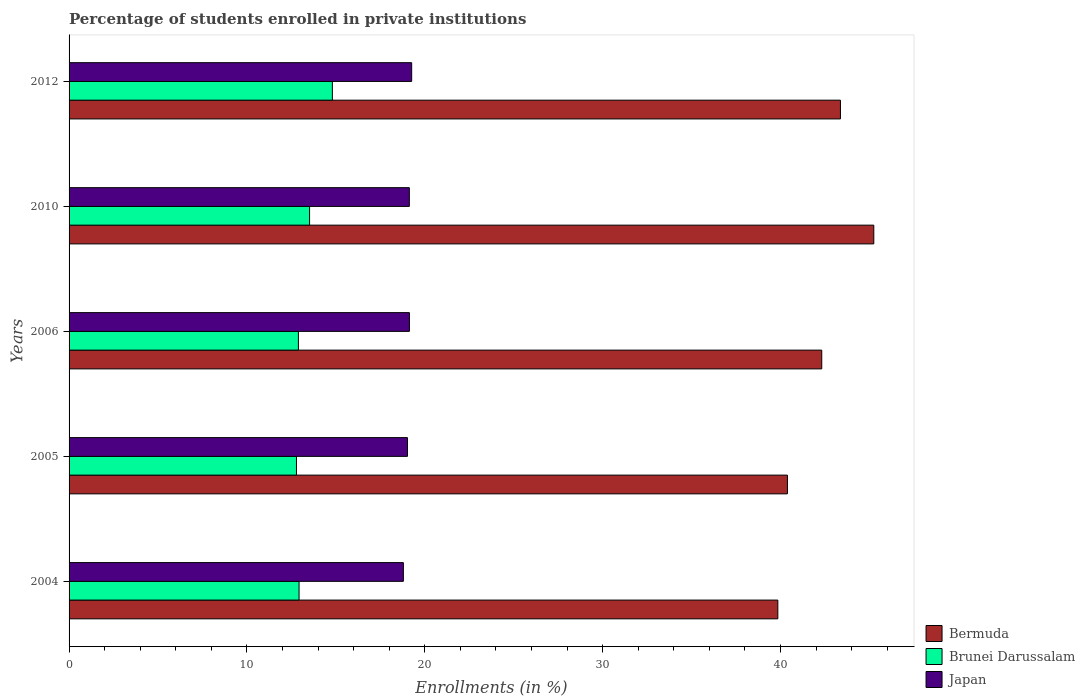How many different coloured bars are there?
Ensure brevity in your answer.  3. Are the number of bars per tick equal to the number of legend labels?
Offer a very short reply. Yes. What is the label of the 1st group of bars from the top?
Provide a succinct answer. 2012. In how many cases, is the number of bars for a given year not equal to the number of legend labels?
Make the answer very short. 0. What is the percentage of trained teachers in Brunei Darussalam in 2006?
Your answer should be compact. 12.89. Across all years, what is the maximum percentage of trained teachers in Brunei Darussalam?
Keep it short and to the point. 14.8. Across all years, what is the minimum percentage of trained teachers in Bermuda?
Offer a very short reply. 39.85. In which year was the percentage of trained teachers in Bermuda maximum?
Provide a succinct answer. 2010. In which year was the percentage of trained teachers in Bermuda minimum?
Provide a succinct answer. 2004. What is the total percentage of trained teachers in Japan in the graph?
Your answer should be very brief. 95.35. What is the difference between the percentage of trained teachers in Bermuda in 2010 and that in 2012?
Provide a short and direct response. 1.88. What is the difference between the percentage of trained teachers in Brunei Darussalam in 2010 and the percentage of trained teachers in Bermuda in 2012?
Provide a short and direct response. -29.85. What is the average percentage of trained teachers in Bermuda per year?
Your answer should be very brief. 42.24. In the year 2012, what is the difference between the percentage of trained teachers in Japan and percentage of trained teachers in Bermuda?
Provide a succinct answer. -24.11. In how many years, is the percentage of trained teachers in Brunei Darussalam greater than 18 %?
Make the answer very short. 0. What is the ratio of the percentage of trained teachers in Brunei Darussalam in 2005 to that in 2006?
Provide a short and direct response. 0.99. Is the percentage of trained teachers in Bermuda in 2006 less than that in 2010?
Provide a succinct answer. Yes. Is the difference between the percentage of trained teachers in Japan in 2010 and 2012 greater than the difference between the percentage of trained teachers in Bermuda in 2010 and 2012?
Offer a terse response. No. What is the difference between the highest and the second highest percentage of trained teachers in Bermuda?
Provide a succinct answer. 1.88. What is the difference between the highest and the lowest percentage of trained teachers in Brunei Darussalam?
Give a very brief answer. 2.02. In how many years, is the percentage of trained teachers in Japan greater than the average percentage of trained teachers in Japan taken over all years?
Your response must be concise. 3. Is the sum of the percentage of trained teachers in Bermuda in 2005 and 2012 greater than the maximum percentage of trained teachers in Japan across all years?
Provide a succinct answer. Yes. What does the 2nd bar from the top in 2012 represents?
Offer a terse response. Brunei Darussalam. How many bars are there?
Offer a terse response. 15. Are all the bars in the graph horizontal?
Your answer should be very brief. Yes. Are the values on the major ticks of X-axis written in scientific E-notation?
Make the answer very short. No. Where does the legend appear in the graph?
Make the answer very short. Bottom right. How are the legend labels stacked?
Offer a terse response. Vertical. What is the title of the graph?
Give a very brief answer. Percentage of students enrolled in private institutions. Does "Azerbaijan" appear as one of the legend labels in the graph?
Offer a very short reply. No. What is the label or title of the X-axis?
Offer a very short reply. Enrollments (in %). What is the Enrollments (in %) of Bermuda in 2004?
Your response must be concise. 39.85. What is the Enrollments (in %) of Brunei Darussalam in 2004?
Provide a short and direct response. 12.93. What is the Enrollments (in %) of Japan in 2004?
Your answer should be compact. 18.8. What is the Enrollments (in %) of Bermuda in 2005?
Give a very brief answer. 40.39. What is the Enrollments (in %) in Brunei Darussalam in 2005?
Ensure brevity in your answer.  12.79. What is the Enrollments (in %) of Japan in 2005?
Offer a terse response. 19.03. What is the Enrollments (in %) in Bermuda in 2006?
Your response must be concise. 42.32. What is the Enrollments (in %) in Brunei Darussalam in 2006?
Your answer should be compact. 12.89. What is the Enrollments (in %) in Japan in 2006?
Your answer should be very brief. 19.14. What is the Enrollments (in %) in Bermuda in 2010?
Make the answer very short. 45.25. What is the Enrollments (in %) in Brunei Darussalam in 2010?
Make the answer very short. 13.52. What is the Enrollments (in %) in Japan in 2010?
Keep it short and to the point. 19.13. What is the Enrollments (in %) of Bermuda in 2012?
Your answer should be compact. 43.37. What is the Enrollments (in %) of Brunei Darussalam in 2012?
Offer a terse response. 14.8. What is the Enrollments (in %) in Japan in 2012?
Keep it short and to the point. 19.26. Across all years, what is the maximum Enrollments (in %) of Bermuda?
Provide a succinct answer. 45.25. Across all years, what is the maximum Enrollments (in %) in Brunei Darussalam?
Offer a terse response. 14.8. Across all years, what is the maximum Enrollments (in %) in Japan?
Give a very brief answer. 19.26. Across all years, what is the minimum Enrollments (in %) of Bermuda?
Your answer should be compact. 39.85. Across all years, what is the minimum Enrollments (in %) of Brunei Darussalam?
Provide a short and direct response. 12.79. Across all years, what is the minimum Enrollments (in %) of Japan?
Provide a short and direct response. 18.8. What is the total Enrollments (in %) of Bermuda in the graph?
Your response must be concise. 211.18. What is the total Enrollments (in %) in Brunei Darussalam in the graph?
Provide a short and direct response. 66.94. What is the total Enrollments (in %) of Japan in the graph?
Make the answer very short. 95.35. What is the difference between the Enrollments (in %) of Bermuda in 2004 and that in 2005?
Make the answer very short. -0.54. What is the difference between the Enrollments (in %) in Brunei Darussalam in 2004 and that in 2005?
Provide a short and direct response. 0.15. What is the difference between the Enrollments (in %) in Japan in 2004 and that in 2005?
Offer a terse response. -0.23. What is the difference between the Enrollments (in %) in Bermuda in 2004 and that in 2006?
Offer a very short reply. -2.47. What is the difference between the Enrollments (in %) of Brunei Darussalam in 2004 and that in 2006?
Provide a short and direct response. 0.04. What is the difference between the Enrollments (in %) in Japan in 2004 and that in 2006?
Offer a very short reply. -0.34. What is the difference between the Enrollments (in %) in Bermuda in 2004 and that in 2010?
Make the answer very short. -5.4. What is the difference between the Enrollments (in %) of Brunei Darussalam in 2004 and that in 2010?
Your response must be concise. -0.59. What is the difference between the Enrollments (in %) in Japan in 2004 and that in 2010?
Provide a short and direct response. -0.34. What is the difference between the Enrollments (in %) of Bermuda in 2004 and that in 2012?
Provide a succinct answer. -3.52. What is the difference between the Enrollments (in %) of Brunei Darussalam in 2004 and that in 2012?
Your answer should be very brief. -1.87. What is the difference between the Enrollments (in %) in Japan in 2004 and that in 2012?
Your answer should be very brief. -0.47. What is the difference between the Enrollments (in %) of Bermuda in 2005 and that in 2006?
Provide a succinct answer. -1.93. What is the difference between the Enrollments (in %) in Brunei Darussalam in 2005 and that in 2006?
Offer a very short reply. -0.11. What is the difference between the Enrollments (in %) in Japan in 2005 and that in 2006?
Your response must be concise. -0.11. What is the difference between the Enrollments (in %) of Bermuda in 2005 and that in 2010?
Offer a terse response. -4.86. What is the difference between the Enrollments (in %) of Brunei Darussalam in 2005 and that in 2010?
Provide a short and direct response. -0.74. What is the difference between the Enrollments (in %) in Japan in 2005 and that in 2010?
Your response must be concise. -0.11. What is the difference between the Enrollments (in %) of Bermuda in 2005 and that in 2012?
Make the answer very short. -2.98. What is the difference between the Enrollments (in %) in Brunei Darussalam in 2005 and that in 2012?
Give a very brief answer. -2.02. What is the difference between the Enrollments (in %) in Japan in 2005 and that in 2012?
Make the answer very short. -0.24. What is the difference between the Enrollments (in %) of Bermuda in 2006 and that in 2010?
Keep it short and to the point. -2.93. What is the difference between the Enrollments (in %) of Brunei Darussalam in 2006 and that in 2010?
Make the answer very short. -0.63. What is the difference between the Enrollments (in %) of Japan in 2006 and that in 2010?
Offer a terse response. 0. What is the difference between the Enrollments (in %) of Bermuda in 2006 and that in 2012?
Make the answer very short. -1.05. What is the difference between the Enrollments (in %) in Brunei Darussalam in 2006 and that in 2012?
Keep it short and to the point. -1.91. What is the difference between the Enrollments (in %) in Japan in 2006 and that in 2012?
Keep it short and to the point. -0.13. What is the difference between the Enrollments (in %) of Bermuda in 2010 and that in 2012?
Offer a very short reply. 1.88. What is the difference between the Enrollments (in %) in Brunei Darussalam in 2010 and that in 2012?
Your answer should be compact. -1.28. What is the difference between the Enrollments (in %) in Japan in 2010 and that in 2012?
Your response must be concise. -0.13. What is the difference between the Enrollments (in %) of Bermuda in 2004 and the Enrollments (in %) of Brunei Darussalam in 2005?
Your answer should be compact. 27.06. What is the difference between the Enrollments (in %) of Bermuda in 2004 and the Enrollments (in %) of Japan in 2005?
Your answer should be very brief. 20.82. What is the difference between the Enrollments (in %) in Brunei Darussalam in 2004 and the Enrollments (in %) in Japan in 2005?
Your answer should be very brief. -6.09. What is the difference between the Enrollments (in %) of Bermuda in 2004 and the Enrollments (in %) of Brunei Darussalam in 2006?
Offer a very short reply. 26.96. What is the difference between the Enrollments (in %) of Bermuda in 2004 and the Enrollments (in %) of Japan in 2006?
Keep it short and to the point. 20.71. What is the difference between the Enrollments (in %) in Brunei Darussalam in 2004 and the Enrollments (in %) in Japan in 2006?
Your response must be concise. -6.2. What is the difference between the Enrollments (in %) of Bermuda in 2004 and the Enrollments (in %) of Brunei Darussalam in 2010?
Ensure brevity in your answer.  26.33. What is the difference between the Enrollments (in %) in Bermuda in 2004 and the Enrollments (in %) in Japan in 2010?
Ensure brevity in your answer.  20.72. What is the difference between the Enrollments (in %) of Brunei Darussalam in 2004 and the Enrollments (in %) of Japan in 2010?
Your response must be concise. -6.2. What is the difference between the Enrollments (in %) in Bermuda in 2004 and the Enrollments (in %) in Brunei Darussalam in 2012?
Ensure brevity in your answer.  25.05. What is the difference between the Enrollments (in %) in Bermuda in 2004 and the Enrollments (in %) in Japan in 2012?
Provide a succinct answer. 20.59. What is the difference between the Enrollments (in %) of Brunei Darussalam in 2004 and the Enrollments (in %) of Japan in 2012?
Your answer should be compact. -6.33. What is the difference between the Enrollments (in %) of Bermuda in 2005 and the Enrollments (in %) of Brunei Darussalam in 2006?
Your response must be concise. 27.5. What is the difference between the Enrollments (in %) in Bermuda in 2005 and the Enrollments (in %) in Japan in 2006?
Make the answer very short. 21.25. What is the difference between the Enrollments (in %) in Brunei Darussalam in 2005 and the Enrollments (in %) in Japan in 2006?
Provide a succinct answer. -6.35. What is the difference between the Enrollments (in %) in Bermuda in 2005 and the Enrollments (in %) in Brunei Darussalam in 2010?
Give a very brief answer. 26.87. What is the difference between the Enrollments (in %) in Bermuda in 2005 and the Enrollments (in %) in Japan in 2010?
Offer a very short reply. 21.26. What is the difference between the Enrollments (in %) in Brunei Darussalam in 2005 and the Enrollments (in %) in Japan in 2010?
Make the answer very short. -6.35. What is the difference between the Enrollments (in %) of Bermuda in 2005 and the Enrollments (in %) of Brunei Darussalam in 2012?
Your answer should be very brief. 25.59. What is the difference between the Enrollments (in %) in Bermuda in 2005 and the Enrollments (in %) in Japan in 2012?
Your answer should be very brief. 21.13. What is the difference between the Enrollments (in %) of Brunei Darussalam in 2005 and the Enrollments (in %) of Japan in 2012?
Make the answer very short. -6.48. What is the difference between the Enrollments (in %) in Bermuda in 2006 and the Enrollments (in %) in Brunei Darussalam in 2010?
Make the answer very short. 28.8. What is the difference between the Enrollments (in %) of Bermuda in 2006 and the Enrollments (in %) of Japan in 2010?
Offer a very short reply. 23.19. What is the difference between the Enrollments (in %) of Brunei Darussalam in 2006 and the Enrollments (in %) of Japan in 2010?
Your response must be concise. -6.24. What is the difference between the Enrollments (in %) in Bermuda in 2006 and the Enrollments (in %) in Brunei Darussalam in 2012?
Give a very brief answer. 27.52. What is the difference between the Enrollments (in %) of Bermuda in 2006 and the Enrollments (in %) of Japan in 2012?
Your answer should be very brief. 23.06. What is the difference between the Enrollments (in %) in Brunei Darussalam in 2006 and the Enrollments (in %) in Japan in 2012?
Provide a short and direct response. -6.37. What is the difference between the Enrollments (in %) of Bermuda in 2010 and the Enrollments (in %) of Brunei Darussalam in 2012?
Keep it short and to the point. 30.44. What is the difference between the Enrollments (in %) of Bermuda in 2010 and the Enrollments (in %) of Japan in 2012?
Offer a very short reply. 25.98. What is the difference between the Enrollments (in %) of Brunei Darussalam in 2010 and the Enrollments (in %) of Japan in 2012?
Provide a succinct answer. -5.74. What is the average Enrollments (in %) of Bermuda per year?
Ensure brevity in your answer.  42.24. What is the average Enrollments (in %) of Brunei Darussalam per year?
Offer a terse response. 13.39. What is the average Enrollments (in %) in Japan per year?
Keep it short and to the point. 19.07. In the year 2004, what is the difference between the Enrollments (in %) of Bermuda and Enrollments (in %) of Brunei Darussalam?
Provide a short and direct response. 26.92. In the year 2004, what is the difference between the Enrollments (in %) of Bermuda and Enrollments (in %) of Japan?
Keep it short and to the point. 21.05. In the year 2004, what is the difference between the Enrollments (in %) of Brunei Darussalam and Enrollments (in %) of Japan?
Your response must be concise. -5.86. In the year 2005, what is the difference between the Enrollments (in %) in Bermuda and Enrollments (in %) in Brunei Darussalam?
Give a very brief answer. 27.61. In the year 2005, what is the difference between the Enrollments (in %) of Bermuda and Enrollments (in %) of Japan?
Make the answer very short. 21.36. In the year 2005, what is the difference between the Enrollments (in %) of Brunei Darussalam and Enrollments (in %) of Japan?
Your response must be concise. -6.24. In the year 2006, what is the difference between the Enrollments (in %) of Bermuda and Enrollments (in %) of Brunei Darussalam?
Provide a short and direct response. 29.42. In the year 2006, what is the difference between the Enrollments (in %) of Bermuda and Enrollments (in %) of Japan?
Your answer should be compact. 23.18. In the year 2006, what is the difference between the Enrollments (in %) in Brunei Darussalam and Enrollments (in %) in Japan?
Offer a very short reply. -6.24. In the year 2010, what is the difference between the Enrollments (in %) in Bermuda and Enrollments (in %) in Brunei Darussalam?
Provide a short and direct response. 31.72. In the year 2010, what is the difference between the Enrollments (in %) of Bermuda and Enrollments (in %) of Japan?
Provide a short and direct response. 26.11. In the year 2010, what is the difference between the Enrollments (in %) of Brunei Darussalam and Enrollments (in %) of Japan?
Offer a terse response. -5.61. In the year 2012, what is the difference between the Enrollments (in %) of Bermuda and Enrollments (in %) of Brunei Darussalam?
Offer a terse response. 28.57. In the year 2012, what is the difference between the Enrollments (in %) of Bermuda and Enrollments (in %) of Japan?
Make the answer very short. 24.11. In the year 2012, what is the difference between the Enrollments (in %) of Brunei Darussalam and Enrollments (in %) of Japan?
Your answer should be very brief. -4.46. What is the ratio of the Enrollments (in %) of Bermuda in 2004 to that in 2005?
Make the answer very short. 0.99. What is the ratio of the Enrollments (in %) in Brunei Darussalam in 2004 to that in 2005?
Your answer should be compact. 1.01. What is the ratio of the Enrollments (in %) in Japan in 2004 to that in 2005?
Your answer should be compact. 0.99. What is the ratio of the Enrollments (in %) of Bermuda in 2004 to that in 2006?
Make the answer very short. 0.94. What is the ratio of the Enrollments (in %) in Brunei Darussalam in 2004 to that in 2006?
Your response must be concise. 1. What is the ratio of the Enrollments (in %) of Japan in 2004 to that in 2006?
Keep it short and to the point. 0.98. What is the ratio of the Enrollments (in %) in Bermuda in 2004 to that in 2010?
Your answer should be very brief. 0.88. What is the ratio of the Enrollments (in %) in Brunei Darussalam in 2004 to that in 2010?
Ensure brevity in your answer.  0.96. What is the ratio of the Enrollments (in %) of Japan in 2004 to that in 2010?
Ensure brevity in your answer.  0.98. What is the ratio of the Enrollments (in %) of Bermuda in 2004 to that in 2012?
Give a very brief answer. 0.92. What is the ratio of the Enrollments (in %) of Brunei Darussalam in 2004 to that in 2012?
Make the answer very short. 0.87. What is the ratio of the Enrollments (in %) of Japan in 2004 to that in 2012?
Offer a terse response. 0.98. What is the ratio of the Enrollments (in %) of Bermuda in 2005 to that in 2006?
Provide a short and direct response. 0.95. What is the ratio of the Enrollments (in %) of Bermuda in 2005 to that in 2010?
Provide a short and direct response. 0.89. What is the ratio of the Enrollments (in %) of Brunei Darussalam in 2005 to that in 2010?
Keep it short and to the point. 0.95. What is the ratio of the Enrollments (in %) in Japan in 2005 to that in 2010?
Provide a short and direct response. 0.99. What is the ratio of the Enrollments (in %) of Bermuda in 2005 to that in 2012?
Give a very brief answer. 0.93. What is the ratio of the Enrollments (in %) in Brunei Darussalam in 2005 to that in 2012?
Offer a very short reply. 0.86. What is the ratio of the Enrollments (in %) in Japan in 2005 to that in 2012?
Your response must be concise. 0.99. What is the ratio of the Enrollments (in %) of Bermuda in 2006 to that in 2010?
Your response must be concise. 0.94. What is the ratio of the Enrollments (in %) in Brunei Darussalam in 2006 to that in 2010?
Provide a short and direct response. 0.95. What is the ratio of the Enrollments (in %) in Bermuda in 2006 to that in 2012?
Ensure brevity in your answer.  0.98. What is the ratio of the Enrollments (in %) of Brunei Darussalam in 2006 to that in 2012?
Your answer should be compact. 0.87. What is the ratio of the Enrollments (in %) of Japan in 2006 to that in 2012?
Make the answer very short. 0.99. What is the ratio of the Enrollments (in %) of Bermuda in 2010 to that in 2012?
Offer a terse response. 1.04. What is the ratio of the Enrollments (in %) in Brunei Darussalam in 2010 to that in 2012?
Provide a short and direct response. 0.91. What is the difference between the highest and the second highest Enrollments (in %) in Bermuda?
Make the answer very short. 1.88. What is the difference between the highest and the second highest Enrollments (in %) of Brunei Darussalam?
Ensure brevity in your answer.  1.28. What is the difference between the highest and the second highest Enrollments (in %) of Japan?
Your response must be concise. 0.13. What is the difference between the highest and the lowest Enrollments (in %) of Bermuda?
Offer a terse response. 5.4. What is the difference between the highest and the lowest Enrollments (in %) of Brunei Darussalam?
Offer a terse response. 2.02. What is the difference between the highest and the lowest Enrollments (in %) in Japan?
Your answer should be very brief. 0.47. 